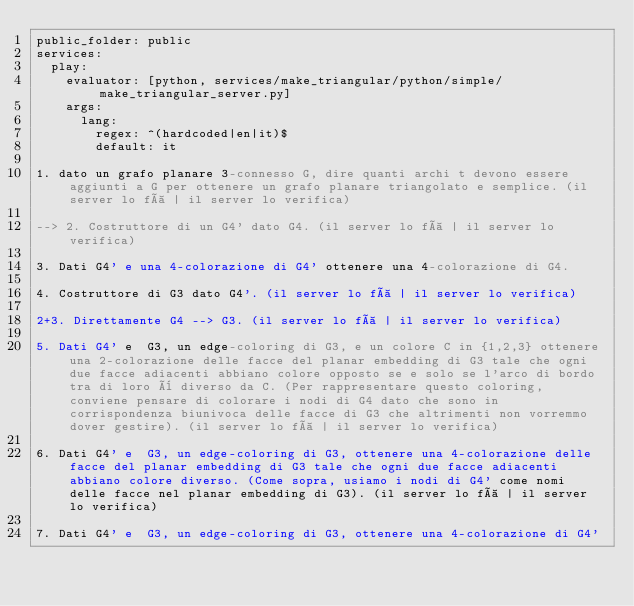Convert code to text. <code><loc_0><loc_0><loc_500><loc_500><_YAML_>public_folder: public
services:
  play:
    evaluator: [python, services/make_triangular/python/simple/make_triangular_server.py]
    args:
      lang:
        regex: ^(hardcoded|en|it)$
        default: it

1. dato un grafo planare 3-connesso G, dire quanti archi t devono essere aggiunti a G per ottenere un grafo planare triangolato e semplice. (il server lo fà | il server lo verifica)

--> 2. Costruttore di un G4' dato G4. (il server lo fà | il server lo verifica)

3. Dati G4' e una 4-colorazione di G4' ottenere una 4-colorazione di G4.

4. Costruttore di G3 dato G4'. (il server lo fà | il server lo verifica)

2+3. Direttamente G4 --> G3. (il server lo fà | il server lo verifica)

5. Dati G4' e  G3, un edge-coloring di G3, e un colore C in {1,2,3} ottenere una 2-colorazione delle facce del planar embedding di G3 tale che ogni due facce adiacenti abbiano colore opposto se e solo se l'arco di bordo tra di loro è diverso da C. (Per rappresentare questo coloring, conviene pensare di colorare i nodi di G4 dato che sono in corrispondenza biunivoca delle facce di G3 che altrimenti non vorremmo dover gestire). (il server lo fà | il server lo verifica)

6. Dati G4' e  G3, un edge-coloring di G3, ottenere una 4-colorazione delle facce del planar embedding di G3 tale che ogni due facce adiacenti abbiano colore diverso. (Come sopra, usiamo i nodi di G4' come nomi delle facce nel planar embedding di G3). (il server lo fà | il server lo verifica)

7. Dati G4' e  G3, un edge-coloring di G3, ottenere una 4-colorazione di G4'
</code> 